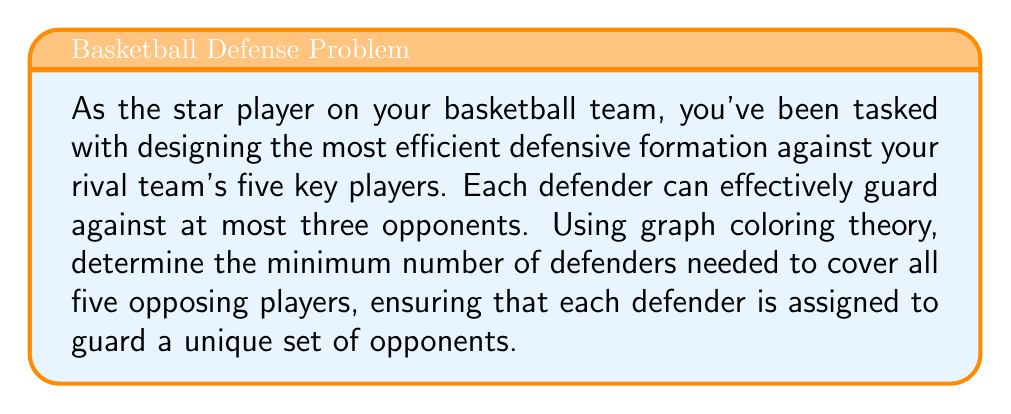Teach me how to tackle this problem. To solve this problem using graph coloring theory, we can follow these steps:

1) First, let's model the problem as a graph. Each opposing player will be represented by a vertex, and an edge will connect two vertices if those players cannot be guarded by the same defender.

2) Given that each defender can guard at most three opponents, any set of four or more opponents must have at least two defenders among them. This means that in our graph, any set of four vertices must form at least one edge.

3) The graph that satisfies this condition is known as a Johnson graph J(5,2). It's a complement of the Petersen graph.

4) Here's a representation of the Johnson J(5,2) graph:

[asy]
unitsize(2cm);
pair[] v={dir(90),dir(18),dir(-54),dir(-126),dir(162)};
for(int i=0; i<5; ++i)
  for(int j=i+1; j<5; ++j)
    draw(v[i]--v[j]);
for(int i=0; i<5; ++i)
  dot(v[i]);
[/asy]

5) Now, our problem reduces to finding the chromatic number of this graph. The chromatic number is the minimum number of colors needed to color the vertices such that no two adjacent vertices have the same color.

6) For the Johnson J(5,2) graph, the chromatic number is known to be 3.

7) In the context of our problem, each color represents a defender, and vertices of the same color represent the players that defender will guard.

8) Therefore, we need a minimum of 3 defenders to efficiently cover all 5 opposing players.

9) One possible coloring (or assignment of defenders) could be:
   Defender 1: Players 1, 2, 3
   Defender 2: Players 1, 4, 5
   Defender 3: Players 2, 4, 5

This assignment ensures that each defender guards at most three players, and all five players are covered.
Answer: The minimum number of defenders needed is 3. 